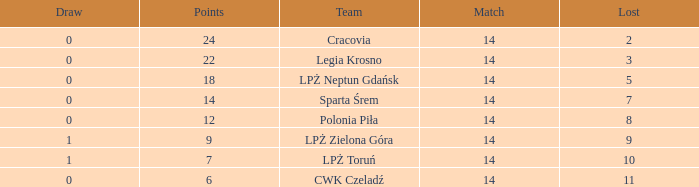What is the highest loss with points less than 7? 11.0. 